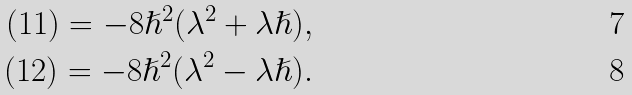Convert formula to latex. <formula><loc_0><loc_0><loc_500><loc_500>( 1 1 ) = - 8 \hslash ^ { 2 } ( \lambda ^ { 2 } + \lambda \hslash ) , \\ ( 1 2 ) = - 8 \hslash ^ { 2 } ( \lambda ^ { 2 } - \lambda \hslash ) .</formula> 